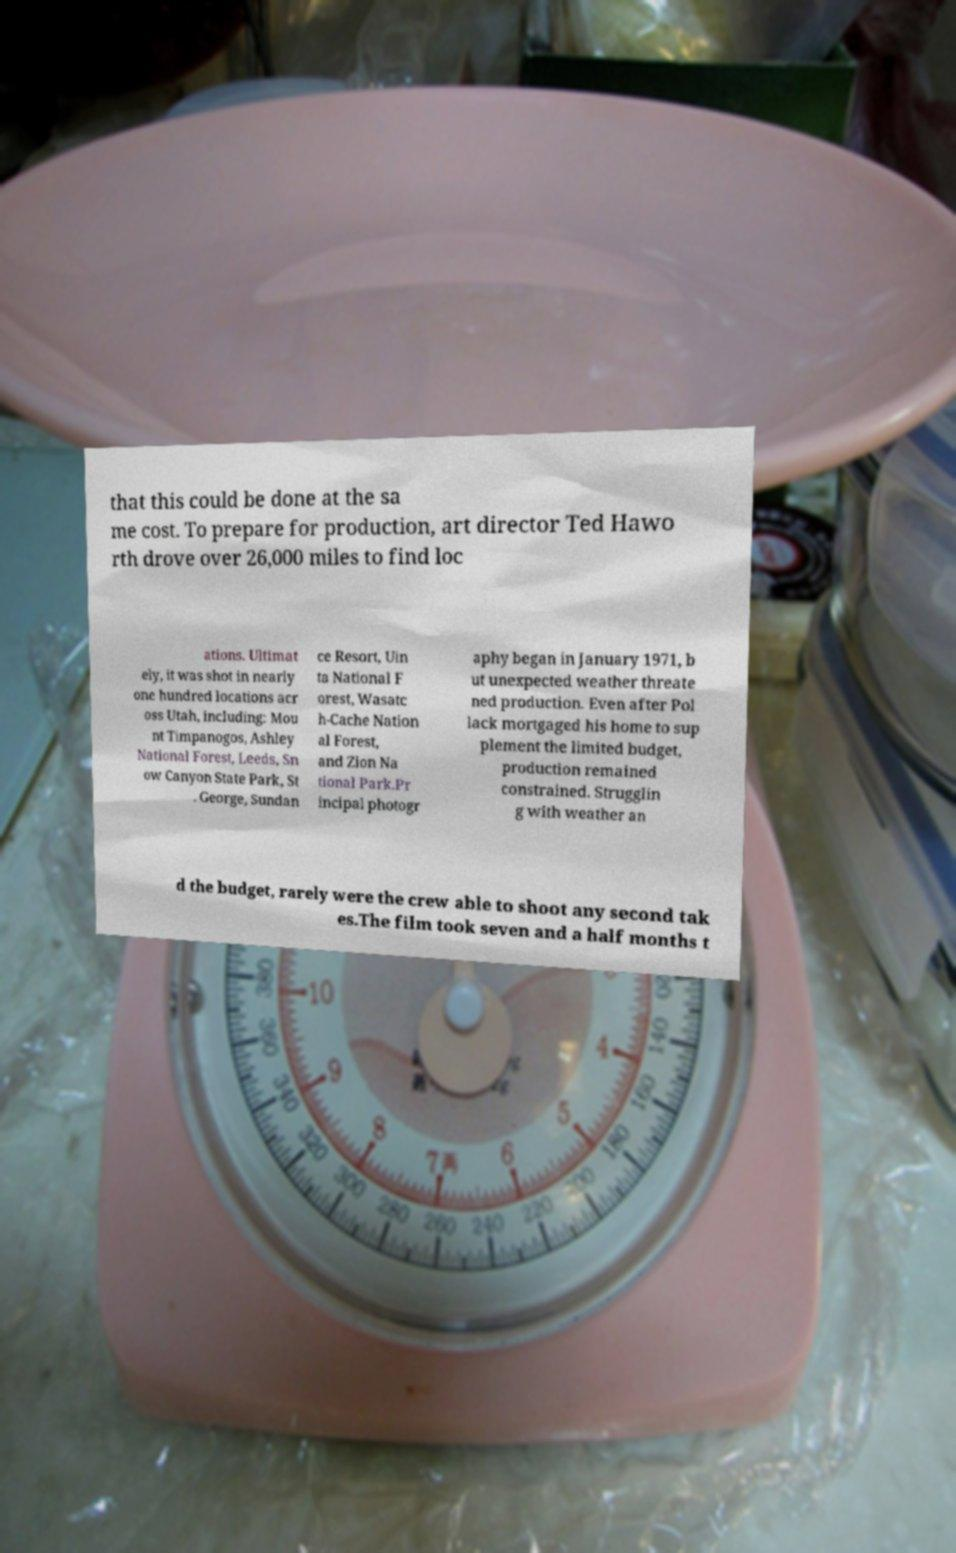For documentation purposes, I need the text within this image transcribed. Could you provide that? that this could be done at the sa me cost. To prepare for production, art director Ted Hawo rth drove over 26,000 miles to find loc ations. Ultimat ely, it was shot in nearly one hundred locations acr oss Utah, including: Mou nt Timpanogos, Ashley National Forest, Leeds, Sn ow Canyon State Park, St . George, Sundan ce Resort, Uin ta National F orest, Wasatc h-Cache Nation al Forest, and Zion Na tional Park.Pr incipal photogr aphy began in January 1971, b ut unexpected weather threate ned production. Even after Pol lack mortgaged his home to sup plement the limited budget, production remained constrained. Strugglin g with weather an d the budget, rarely were the crew able to shoot any second tak es.The film took seven and a half months t 